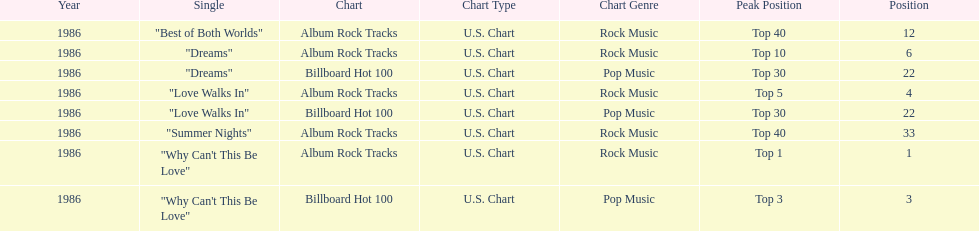Which is the most popular single on the album? Why Can't This Be Love. 